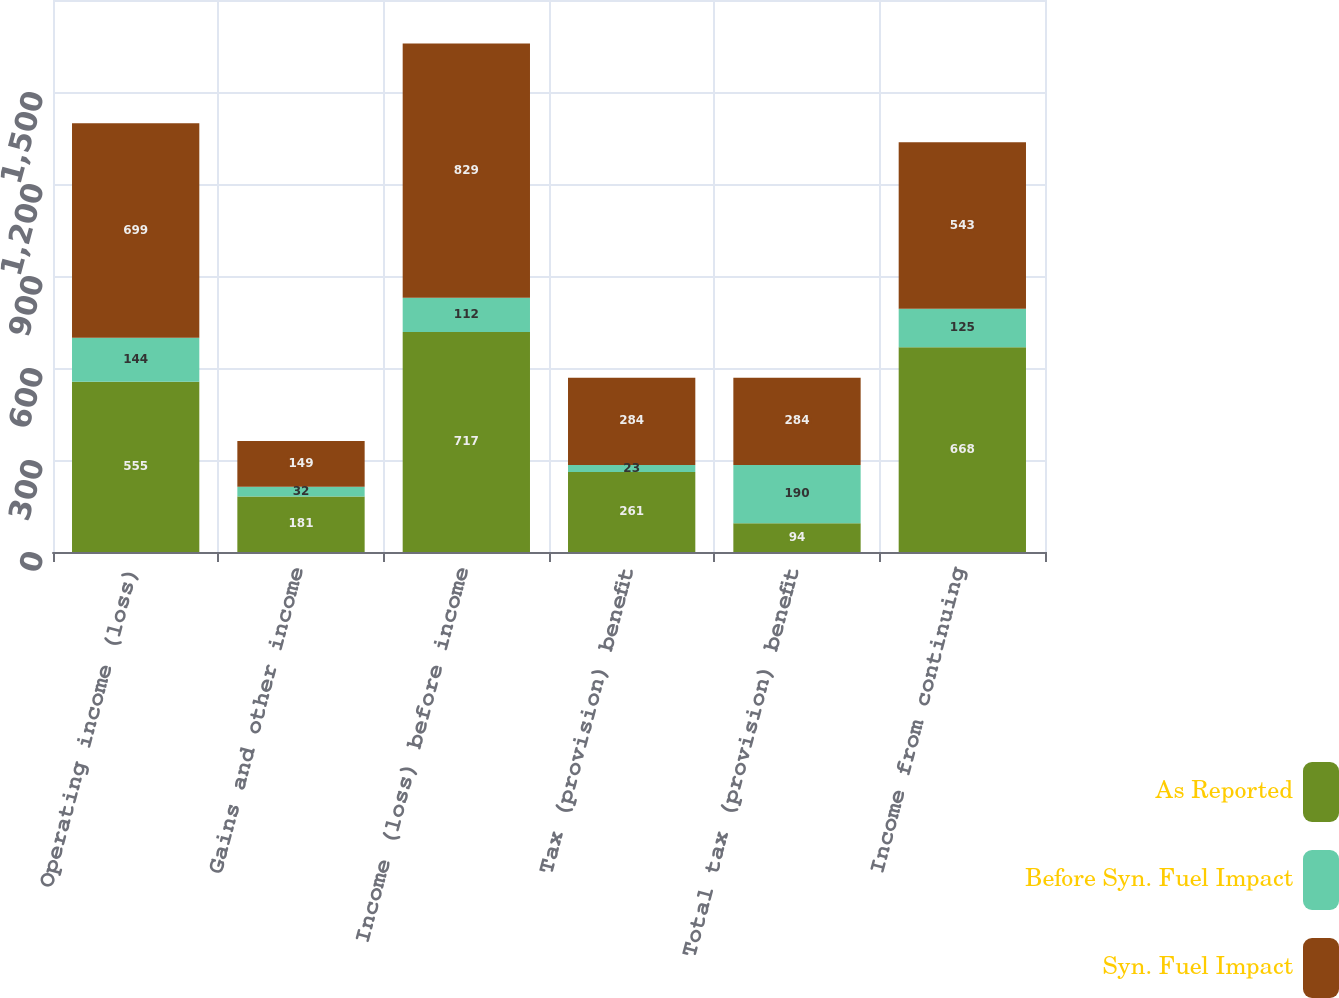Convert chart. <chart><loc_0><loc_0><loc_500><loc_500><stacked_bar_chart><ecel><fcel>Operating income (loss)<fcel>Gains and other income<fcel>Income (loss) before income<fcel>Tax (provision) benefit<fcel>Total tax (provision) benefit<fcel>Income from continuing<nl><fcel>As Reported<fcel>555<fcel>181<fcel>717<fcel>261<fcel>94<fcel>668<nl><fcel>Before Syn. Fuel Impact<fcel>144<fcel>32<fcel>112<fcel>23<fcel>190<fcel>125<nl><fcel>Syn. Fuel Impact<fcel>699<fcel>149<fcel>829<fcel>284<fcel>284<fcel>543<nl></chart> 